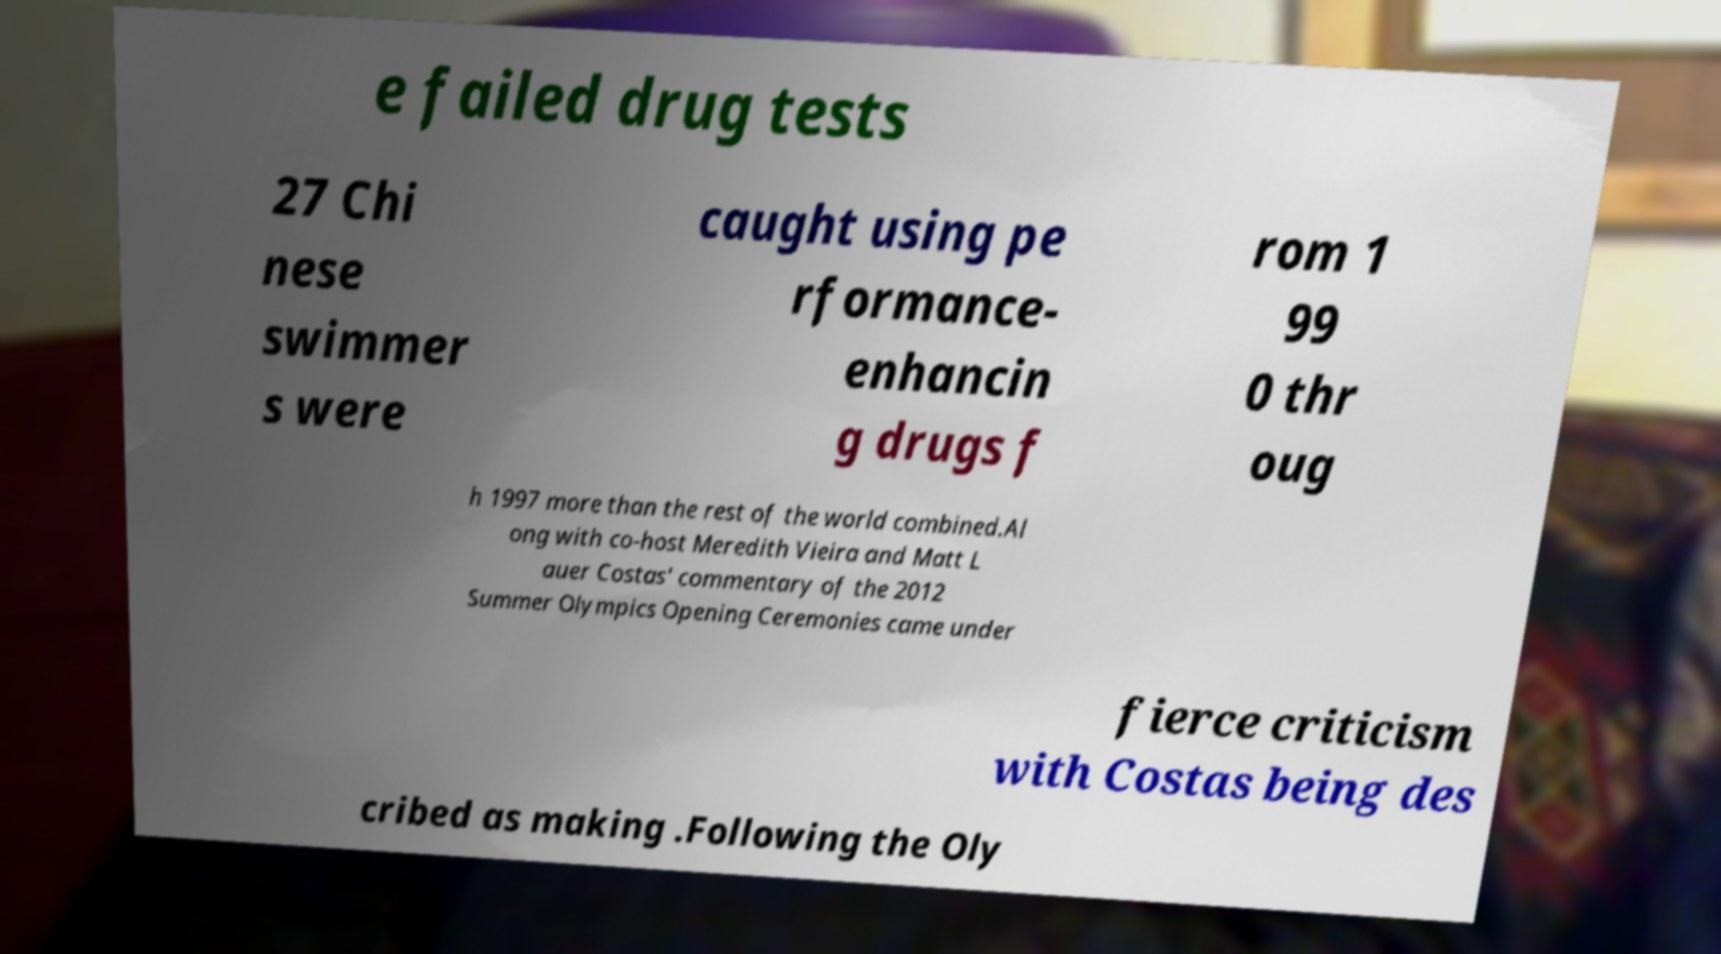What messages or text are displayed in this image? I need them in a readable, typed format. e failed drug tests 27 Chi nese swimmer s were caught using pe rformance- enhancin g drugs f rom 1 99 0 thr oug h 1997 more than the rest of the world combined.Al ong with co-host Meredith Vieira and Matt L auer Costas' commentary of the 2012 Summer Olympics Opening Ceremonies came under fierce criticism with Costas being des cribed as making .Following the Oly 